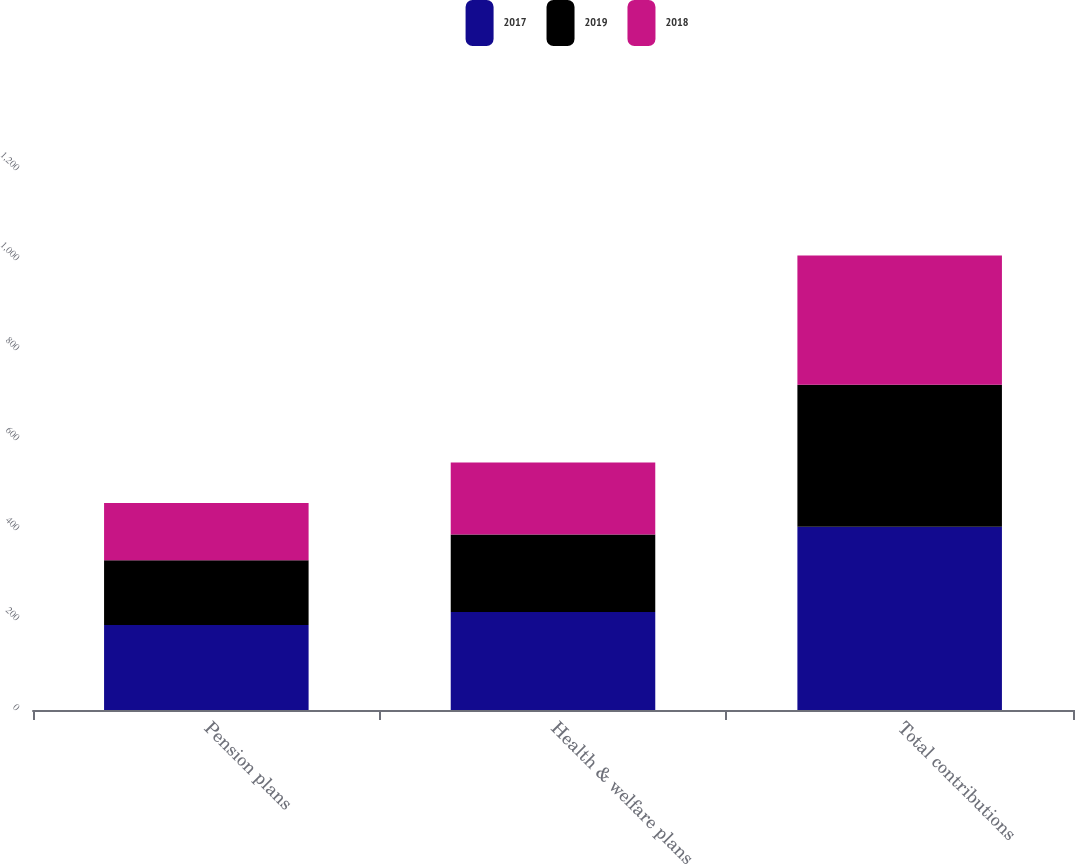Convert chart. <chart><loc_0><loc_0><loc_500><loc_500><stacked_bar_chart><ecel><fcel>Pension plans<fcel>Health & welfare plans<fcel>Total contributions<nl><fcel>2017<fcel>189<fcel>218<fcel>407<nl><fcel>2019<fcel>144<fcel>172<fcel>316<nl><fcel>2018<fcel>127<fcel>160<fcel>287<nl></chart> 